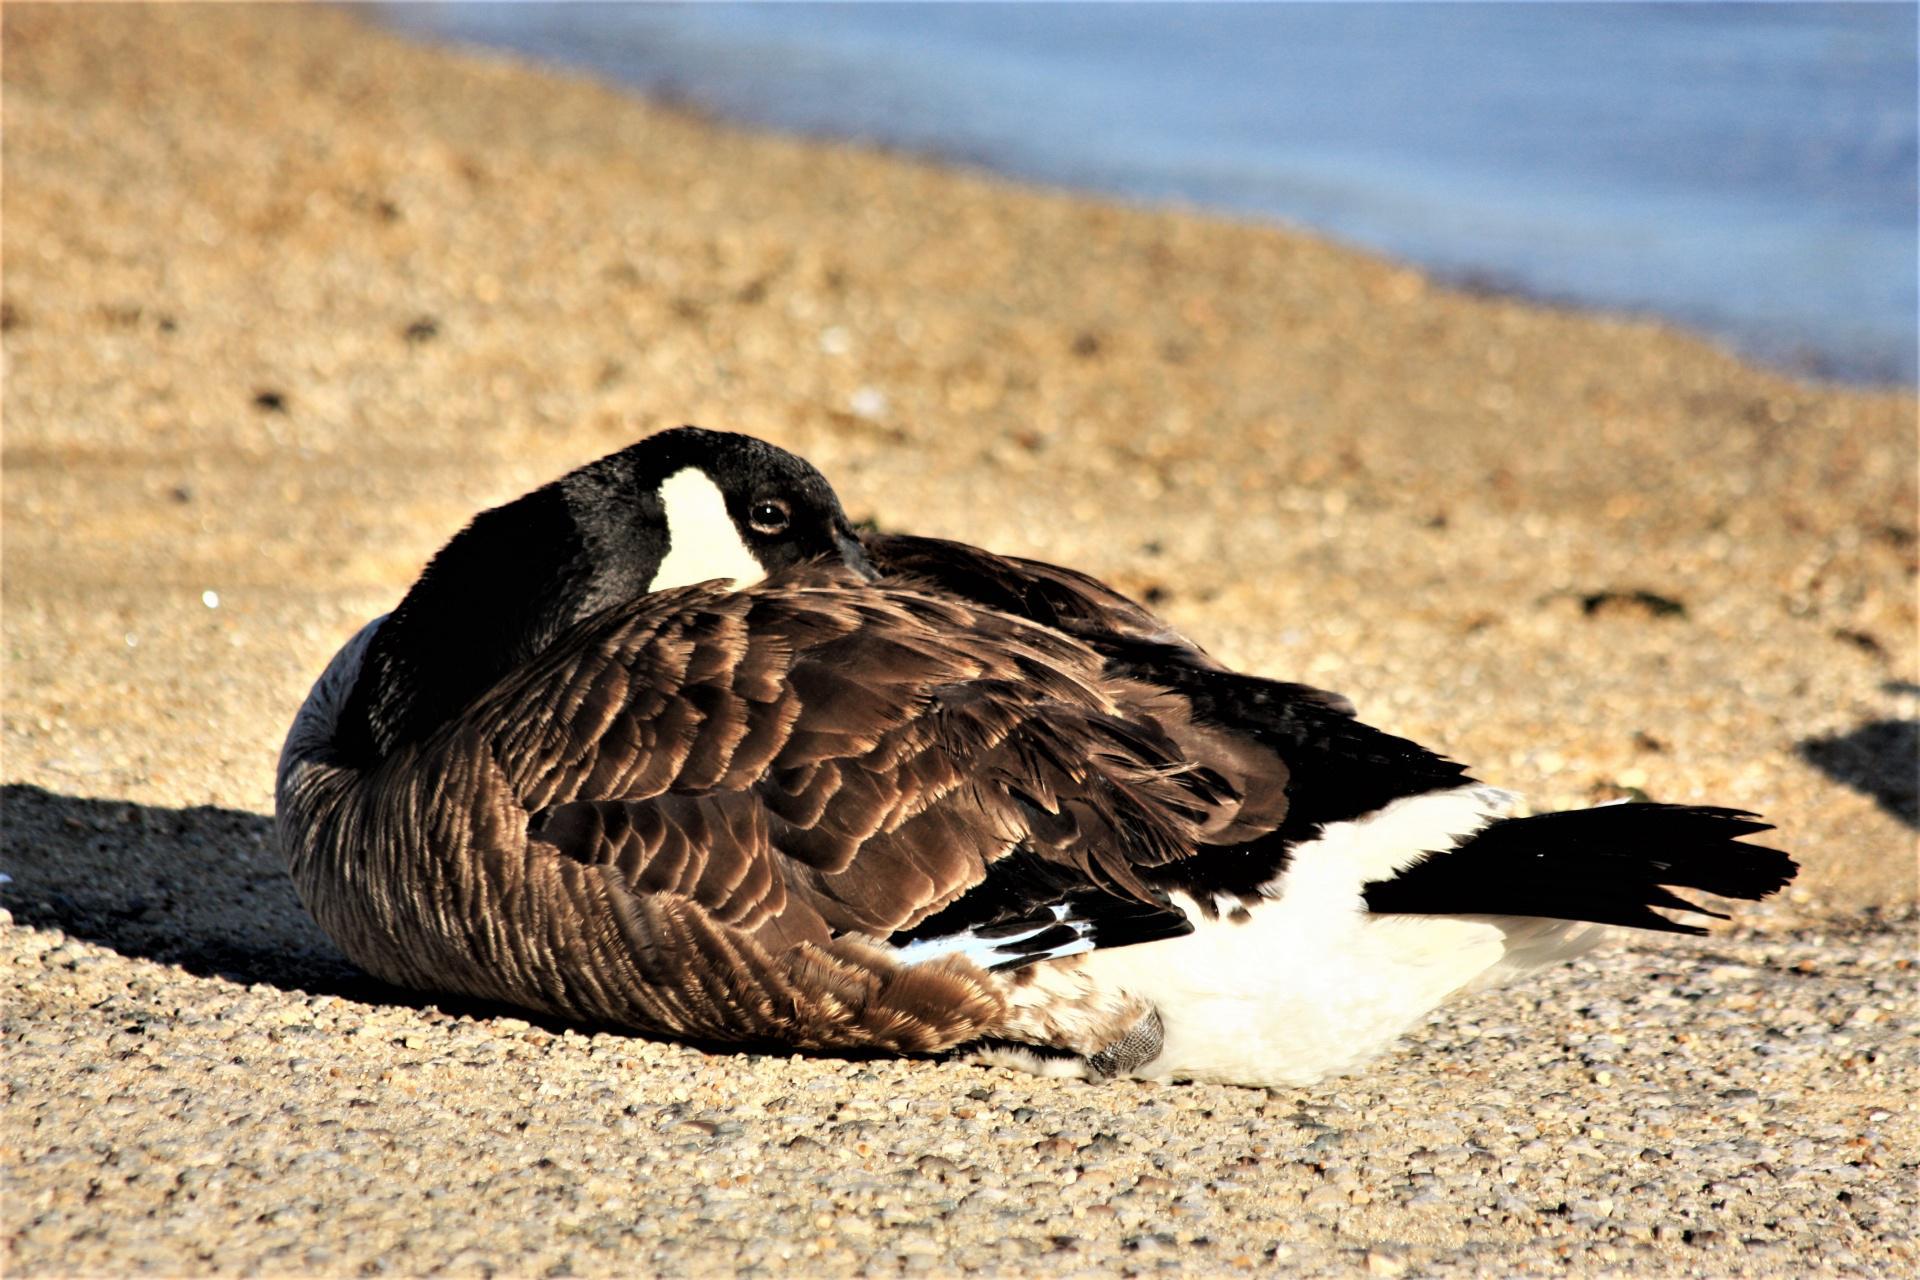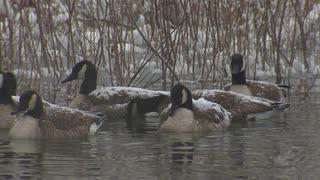The first image is the image on the left, the second image is the image on the right. Examine the images to the left and right. Is the description "An image shows one bird in the water, with its neck turned backward." accurate? Answer yes or no. No. The first image is the image on the left, the second image is the image on the right. Evaluate the accuracy of this statement regarding the images: "4 geese total with two having heads tucked in their feathers". Is it true? Answer yes or no. No. 